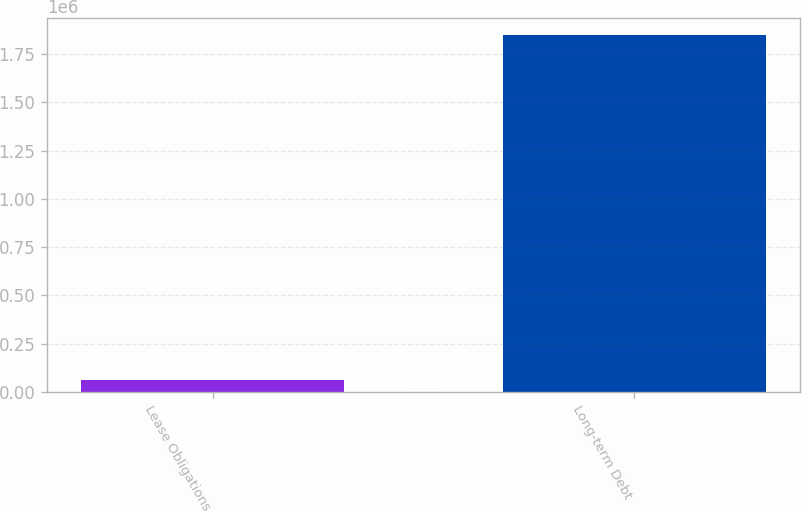Convert chart. <chart><loc_0><loc_0><loc_500><loc_500><bar_chart><fcel>Lease Obligations<fcel>Long-term Debt<nl><fcel>58643<fcel>1.84609e+06<nl></chart> 